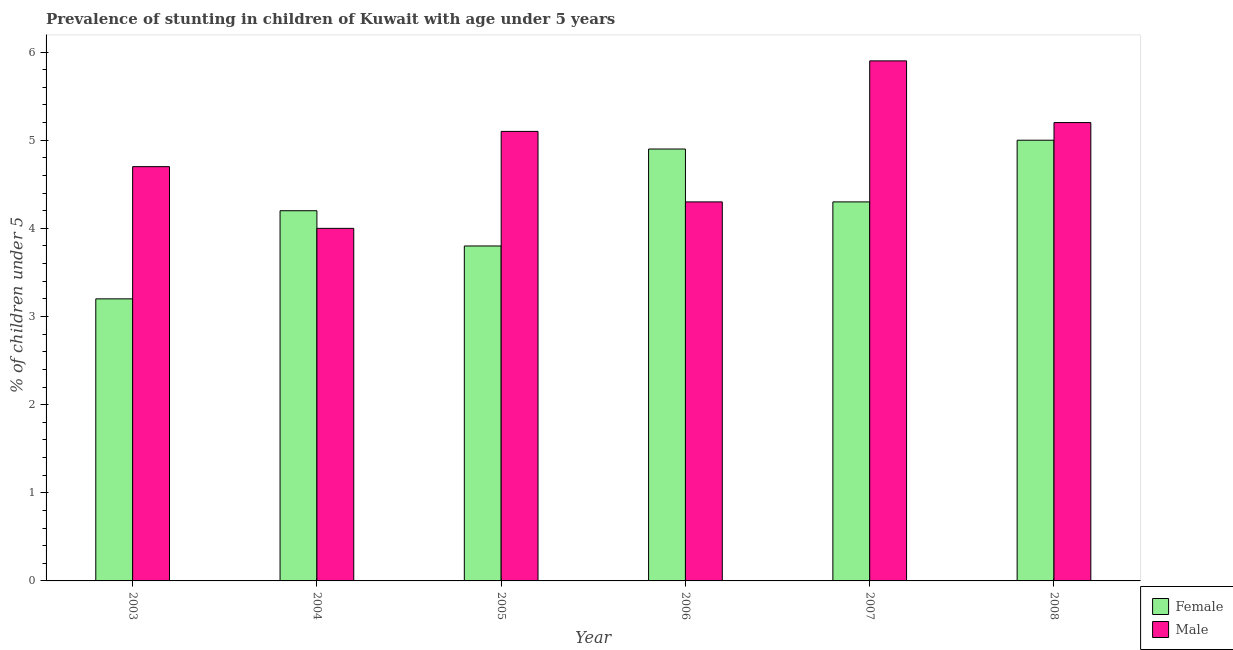How many different coloured bars are there?
Your answer should be very brief. 2. Are the number of bars on each tick of the X-axis equal?
Your answer should be very brief. Yes. What is the percentage of stunted male children in 2006?
Provide a succinct answer. 4.3. Across all years, what is the minimum percentage of stunted female children?
Your answer should be very brief. 3.2. In which year was the percentage of stunted female children maximum?
Ensure brevity in your answer.  2008. What is the total percentage of stunted female children in the graph?
Give a very brief answer. 25.4. What is the difference between the percentage of stunted female children in 2005 and the percentage of stunted male children in 2006?
Keep it short and to the point. -1.1. What is the average percentage of stunted male children per year?
Your answer should be very brief. 4.87. In the year 2007, what is the difference between the percentage of stunted male children and percentage of stunted female children?
Your response must be concise. 0. In how many years, is the percentage of stunted female children greater than 4.4 %?
Your answer should be very brief. 2. What is the ratio of the percentage of stunted male children in 2004 to that in 2007?
Offer a very short reply. 0.68. Is the difference between the percentage of stunted male children in 2003 and 2004 greater than the difference between the percentage of stunted female children in 2003 and 2004?
Give a very brief answer. No. What is the difference between the highest and the second highest percentage of stunted male children?
Your answer should be very brief. 0.7. What is the difference between the highest and the lowest percentage of stunted male children?
Your response must be concise. 1.9. In how many years, is the percentage of stunted female children greater than the average percentage of stunted female children taken over all years?
Offer a very short reply. 3. What does the 1st bar from the right in 2003 represents?
Offer a very short reply. Male. How many bars are there?
Your answer should be very brief. 12. What is the difference between two consecutive major ticks on the Y-axis?
Make the answer very short. 1. Does the graph contain any zero values?
Provide a succinct answer. No. Does the graph contain grids?
Provide a succinct answer. No. Where does the legend appear in the graph?
Your response must be concise. Bottom right. How are the legend labels stacked?
Provide a succinct answer. Vertical. What is the title of the graph?
Provide a succinct answer. Prevalence of stunting in children of Kuwait with age under 5 years. Does "Long-term debt" appear as one of the legend labels in the graph?
Your answer should be very brief. No. What is the label or title of the X-axis?
Offer a terse response. Year. What is the label or title of the Y-axis?
Keep it short and to the point.  % of children under 5. What is the  % of children under 5 of Female in 2003?
Provide a succinct answer. 3.2. What is the  % of children under 5 of Male in 2003?
Provide a succinct answer. 4.7. What is the  % of children under 5 of Female in 2004?
Keep it short and to the point. 4.2. What is the  % of children under 5 in Male in 2004?
Make the answer very short. 4. What is the  % of children under 5 of Female in 2005?
Make the answer very short. 3.8. What is the  % of children under 5 in Male in 2005?
Keep it short and to the point. 5.1. What is the  % of children under 5 of Female in 2006?
Your answer should be compact. 4.9. What is the  % of children under 5 of Male in 2006?
Give a very brief answer. 4.3. What is the  % of children under 5 in Female in 2007?
Ensure brevity in your answer.  4.3. What is the  % of children under 5 in Male in 2007?
Your response must be concise. 5.9. What is the  % of children under 5 in Male in 2008?
Your answer should be very brief. 5.2. Across all years, what is the maximum  % of children under 5 in Male?
Your answer should be very brief. 5.9. Across all years, what is the minimum  % of children under 5 in Female?
Your answer should be very brief. 3.2. Across all years, what is the minimum  % of children under 5 of Male?
Ensure brevity in your answer.  4. What is the total  % of children under 5 in Female in the graph?
Give a very brief answer. 25.4. What is the total  % of children under 5 of Male in the graph?
Ensure brevity in your answer.  29.2. What is the difference between the  % of children under 5 in Male in 2003 and that in 2004?
Ensure brevity in your answer.  0.7. What is the difference between the  % of children under 5 of Male in 2003 and that in 2005?
Provide a short and direct response. -0.4. What is the difference between the  % of children under 5 of Female in 2003 and that in 2006?
Your answer should be compact. -1.7. What is the difference between the  % of children under 5 in Male in 2003 and that in 2006?
Your answer should be very brief. 0.4. What is the difference between the  % of children under 5 in Female in 2003 and that in 2007?
Your answer should be compact. -1.1. What is the difference between the  % of children under 5 in Male in 2003 and that in 2007?
Give a very brief answer. -1.2. What is the difference between the  % of children under 5 in Female in 2003 and that in 2008?
Your answer should be compact. -1.8. What is the difference between the  % of children under 5 in Male in 2003 and that in 2008?
Your answer should be very brief. -0.5. What is the difference between the  % of children under 5 of Female in 2004 and that in 2005?
Provide a short and direct response. 0.4. What is the difference between the  % of children under 5 of Female in 2004 and that in 2006?
Offer a terse response. -0.7. What is the difference between the  % of children under 5 of Male in 2004 and that in 2006?
Ensure brevity in your answer.  -0.3. What is the difference between the  % of children under 5 of Female in 2004 and that in 2007?
Give a very brief answer. -0.1. What is the difference between the  % of children under 5 of Male in 2004 and that in 2007?
Make the answer very short. -1.9. What is the difference between the  % of children under 5 in Male in 2004 and that in 2008?
Give a very brief answer. -1.2. What is the difference between the  % of children under 5 in Female in 2005 and that in 2006?
Give a very brief answer. -1.1. What is the difference between the  % of children under 5 of Male in 2005 and that in 2007?
Offer a very short reply. -0.8. What is the difference between the  % of children under 5 of Male in 2005 and that in 2008?
Your response must be concise. -0.1. What is the difference between the  % of children under 5 of Female in 2006 and that in 2007?
Make the answer very short. 0.6. What is the difference between the  % of children under 5 of Female in 2006 and that in 2008?
Offer a very short reply. -0.1. What is the difference between the  % of children under 5 of Male in 2006 and that in 2008?
Give a very brief answer. -0.9. What is the difference between the  % of children under 5 of Female in 2007 and that in 2008?
Keep it short and to the point. -0.7. What is the difference between the  % of children under 5 of Female in 2003 and the  % of children under 5 of Male in 2005?
Your answer should be compact. -1.9. What is the difference between the  % of children under 5 of Female in 2003 and the  % of children under 5 of Male in 2006?
Make the answer very short. -1.1. What is the difference between the  % of children under 5 in Female in 2004 and the  % of children under 5 in Male in 2007?
Provide a short and direct response. -1.7. What is the difference between the  % of children under 5 of Female in 2004 and the  % of children under 5 of Male in 2008?
Offer a very short reply. -1. What is the difference between the  % of children under 5 of Female in 2005 and the  % of children under 5 of Male in 2006?
Give a very brief answer. -0.5. What is the difference between the  % of children under 5 of Female in 2006 and the  % of children under 5 of Male in 2008?
Offer a very short reply. -0.3. What is the average  % of children under 5 of Female per year?
Offer a very short reply. 4.23. What is the average  % of children under 5 of Male per year?
Your response must be concise. 4.87. In the year 2005, what is the difference between the  % of children under 5 of Female and  % of children under 5 of Male?
Ensure brevity in your answer.  -1.3. In the year 2006, what is the difference between the  % of children under 5 in Female and  % of children under 5 in Male?
Give a very brief answer. 0.6. In the year 2007, what is the difference between the  % of children under 5 of Female and  % of children under 5 of Male?
Your answer should be very brief. -1.6. What is the ratio of the  % of children under 5 in Female in 2003 to that in 2004?
Offer a terse response. 0.76. What is the ratio of the  % of children under 5 in Male in 2003 to that in 2004?
Offer a terse response. 1.18. What is the ratio of the  % of children under 5 in Female in 2003 to that in 2005?
Your answer should be very brief. 0.84. What is the ratio of the  % of children under 5 in Male in 2003 to that in 2005?
Make the answer very short. 0.92. What is the ratio of the  % of children under 5 of Female in 2003 to that in 2006?
Make the answer very short. 0.65. What is the ratio of the  % of children under 5 in Male in 2003 to that in 2006?
Offer a very short reply. 1.09. What is the ratio of the  % of children under 5 of Female in 2003 to that in 2007?
Your response must be concise. 0.74. What is the ratio of the  % of children under 5 in Male in 2003 to that in 2007?
Your answer should be very brief. 0.8. What is the ratio of the  % of children under 5 of Female in 2003 to that in 2008?
Provide a succinct answer. 0.64. What is the ratio of the  % of children under 5 of Male in 2003 to that in 2008?
Offer a very short reply. 0.9. What is the ratio of the  % of children under 5 of Female in 2004 to that in 2005?
Make the answer very short. 1.11. What is the ratio of the  % of children under 5 of Male in 2004 to that in 2005?
Make the answer very short. 0.78. What is the ratio of the  % of children under 5 in Male in 2004 to that in 2006?
Offer a terse response. 0.93. What is the ratio of the  % of children under 5 of Female in 2004 to that in 2007?
Make the answer very short. 0.98. What is the ratio of the  % of children under 5 of Male in 2004 to that in 2007?
Provide a short and direct response. 0.68. What is the ratio of the  % of children under 5 in Female in 2004 to that in 2008?
Offer a terse response. 0.84. What is the ratio of the  % of children under 5 in Male in 2004 to that in 2008?
Your answer should be very brief. 0.77. What is the ratio of the  % of children under 5 of Female in 2005 to that in 2006?
Offer a terse response. 0.78. What is the ratio of the  % of children under 5 of Male in 2005 to that in 2006?
Offer a very short reply. 1.19. What is the ratio of the  % of children under 5 of Female in 2005 to that in 2007?
Your response must be concise. 0.88. What is the ratio of the  % of children under 5 in Male in 2005 to that in 2007?
Keep it short and to the point. 0.86. What is the ratio of the  % of children under 5 in Female in 2005 to that in 2008?
Offer a terse response. 0.76. What is the ratio of the  % of children under 5 in Male in 2005 to that in 2008?
Ensure brevity in your answer.  0.98. What is the ratio of the  % of children under 5 of Female in 2006 to that in 2007?
Provide a succinct answer. 1.14. What is the ratio of the  % of children under 5 in Male in 2006 to that in 2007?
Give a very brief answer. 0.73. What is the ratio of the  % of children under 5 in Female in 2006 to that in 2008?
Give a very brief answer. 0.98. What is the ratio of the  % of children under 5 of Male in 2006 to that in 2008?
Your answer should be compact. 0.83. What is the ratio of the  % of children under 5 of Female in 2007 to that in 2008?
Offer a very short reply. 0.86. What is the ratio of the  % of children under 5 in Male in 2007 to that in 2008?
Offer a very short reply. 1.13. What is the difference between the highest and the second highest  % of children under 5 in Male?
Your answer should be compact. 0.7. What is the difference between the highest and the lowest  % of children under 5 in Male?
Your answer should be compact. 1.9. 